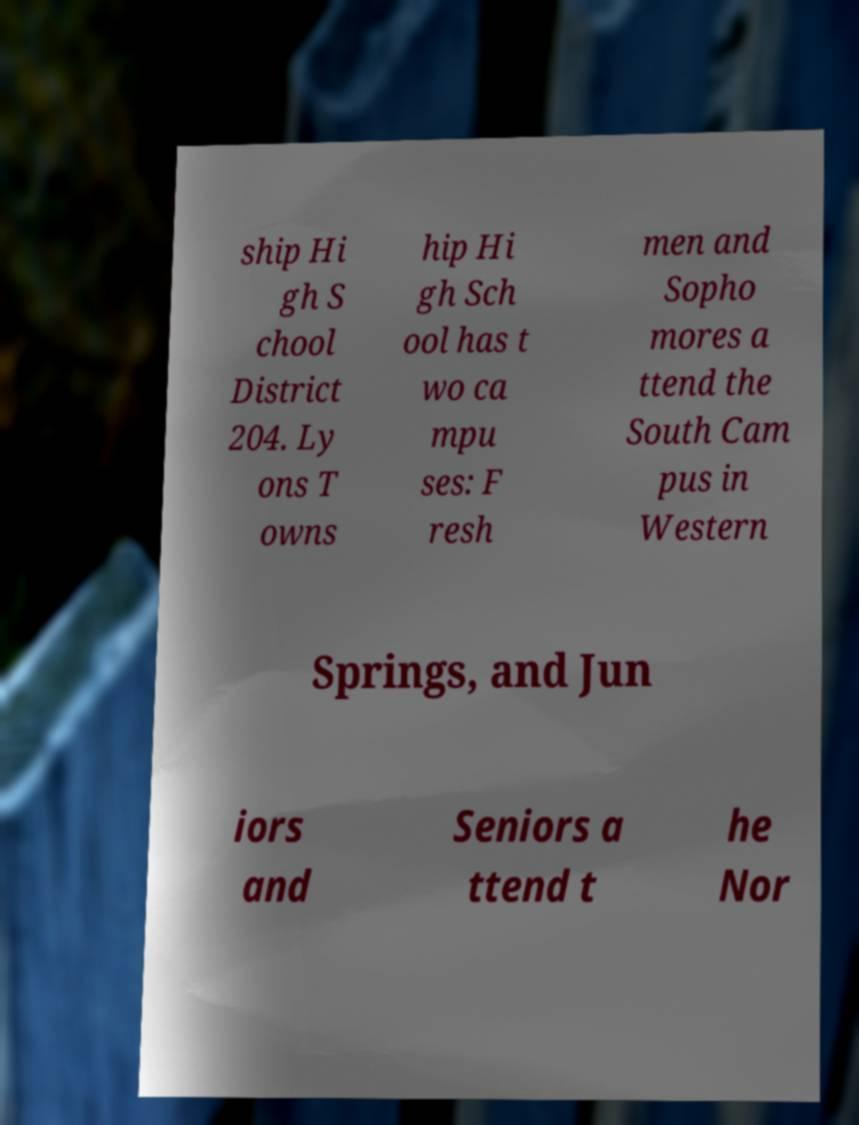Please read and relay the text visible in this image. What does it say? ship Hi gh S chool District 204. Ly ons T owns hip Hi gh Sch ool has t wo ca mpu ses: F resh men and Sopho mores a ttend the South Cam pus in Western Springs, and Jun iors and Seniors a ttend t he Nor 